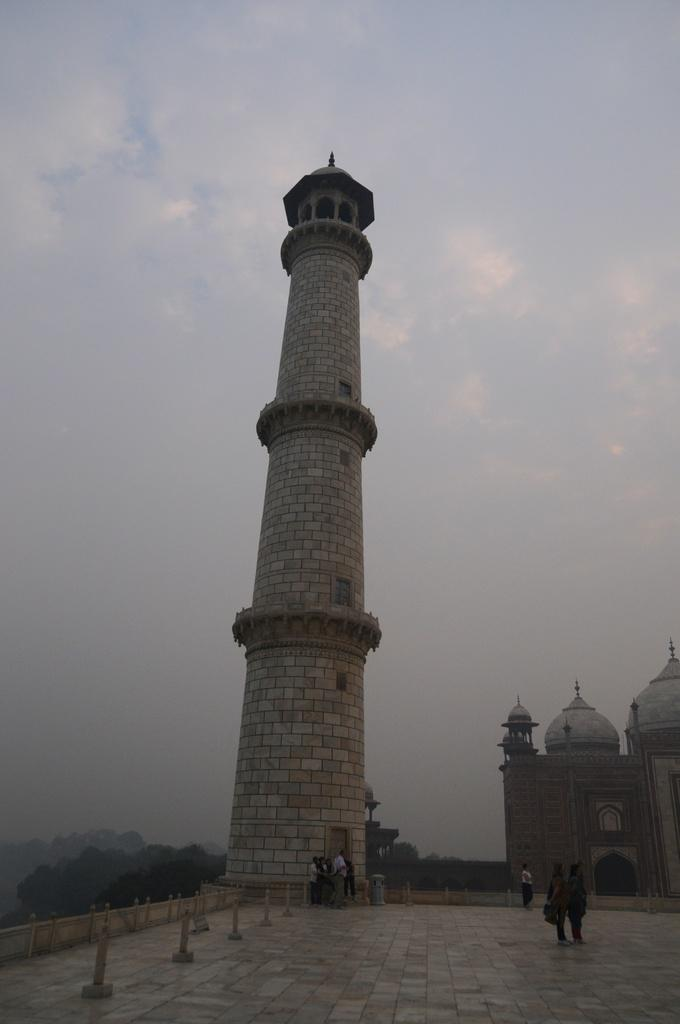What structure is located on the right side of the image? There is a monument on the right side of the image. What can be seen in the center of the image? There is a minar in the center of the image. Who or what is present at the bottom of the image? There are people at the bottom of the image. What type of vegetation is visible in the background of the image? There are trees in the background of the image. What is visible in the background of the image besides the trees? The sky is visible in the background of the image. How many beads are hanging from the minar in the image? There are no beads present in the image; the minar is a tall, slender tower. What type of jar is visible on the monument in the image? There is no jar present on the monument in the image. 